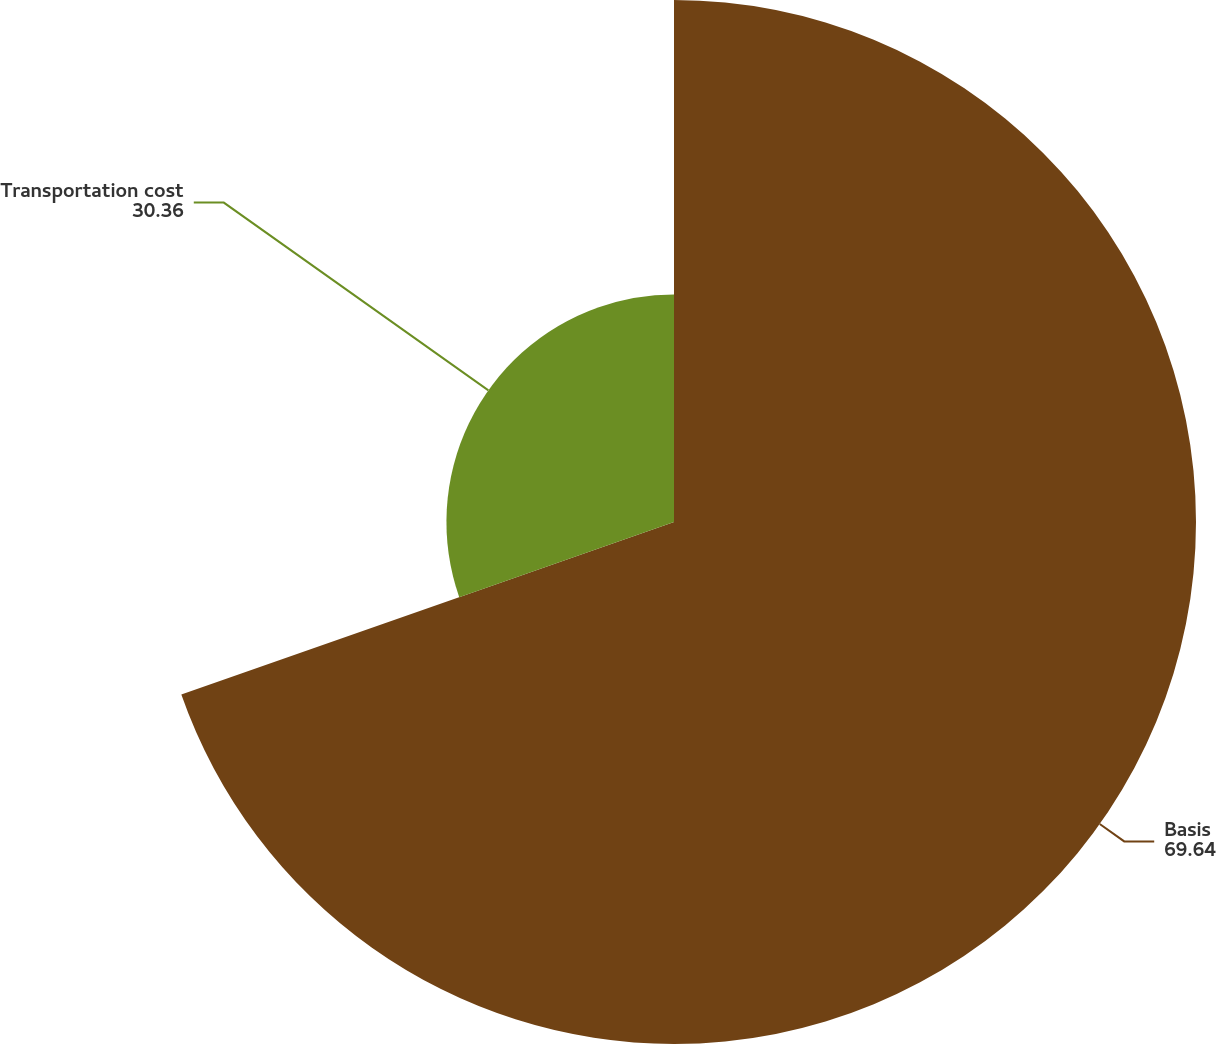<chart> <loc_0><loc_0><loc_500><loc_500><pie_chart><fcel>Basis<fcel>Transportation cost<nl><fcel>69.64%<fcel>30.36%<nl></chart> 